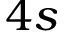<formula> <loc_0><loc_0><loc_500><loc_500>4 s</formula> 